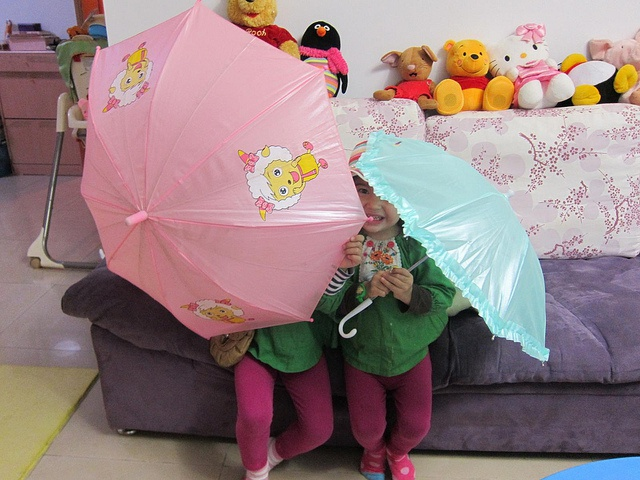Describe the objects in this image and their specific colors. I can see couch in darkgray, lightgray, black, and purple tones, umbrella in darkgray, lightpink, salmon, pink, and lightgray tones, umbrella in darkgray, lightblue, and gray tones, people in darkgray, black, maroon, darkgreen, and brown tones, and people in darkgray, black, maroon, darkgreen, and purple tones in this image. 